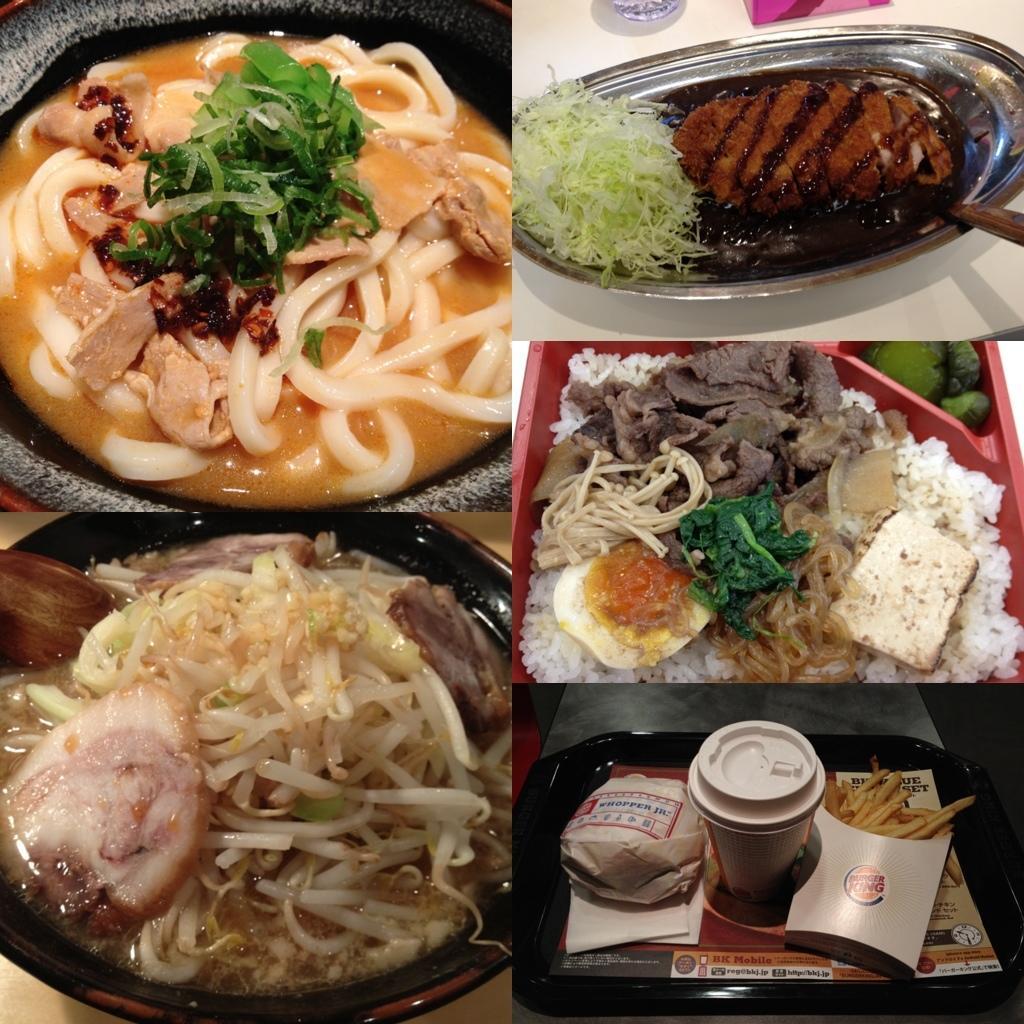Can you describe this image briefly? In this picture we can see collage frames. On the bottom right we can see glass, potato chips, cotton box, pamphlet, tissue paper and cover which are kept on the table. On the right, in a red plate we can see green vegetable, meat, noodle, mint, bread, onion fried, rice and egg which is kept on the table. On the top right we can see the cabbage pieces, bread, chocolate and spoon in the bowl. On the top left we can see on noodles soup in a bowl. On the bottom left we can see onion pieces in a liquid which is kept in a bowl. 